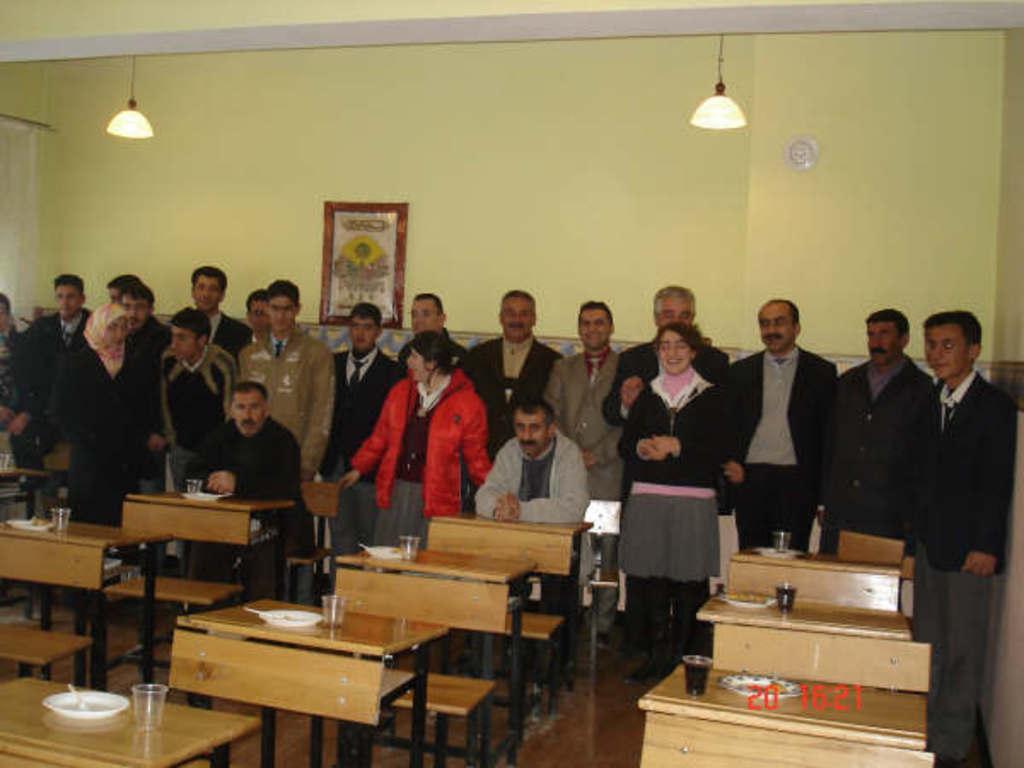In one or two sentences, can you explain what this image depicts? In this image i can see group of people some are standing and some are sitting, in front of them there are few benches, a glasses and bowl. At the background i can see a frame attached to a wall on the top there is a light. 